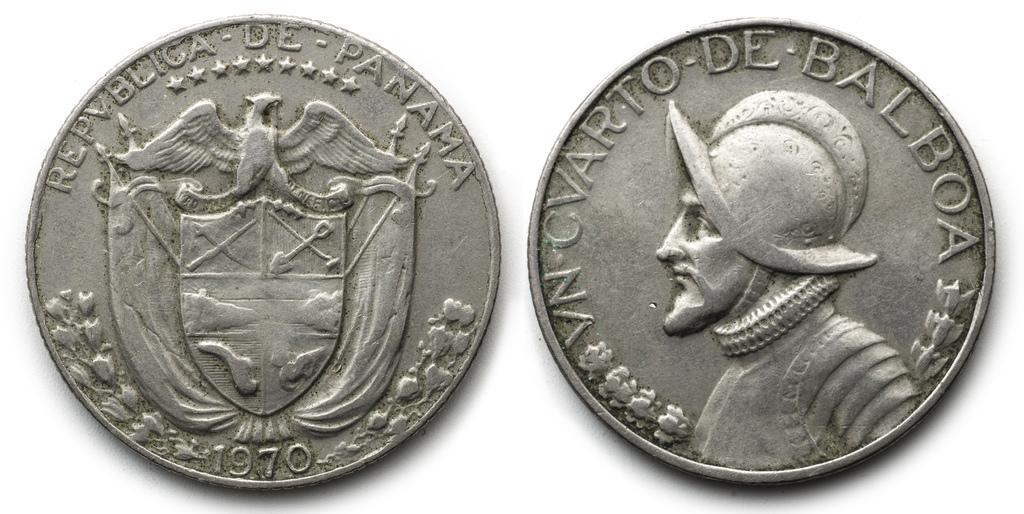<image>
Share a concise interpretation of the image provided. A front and back view of a coin with Balboa in the front. 